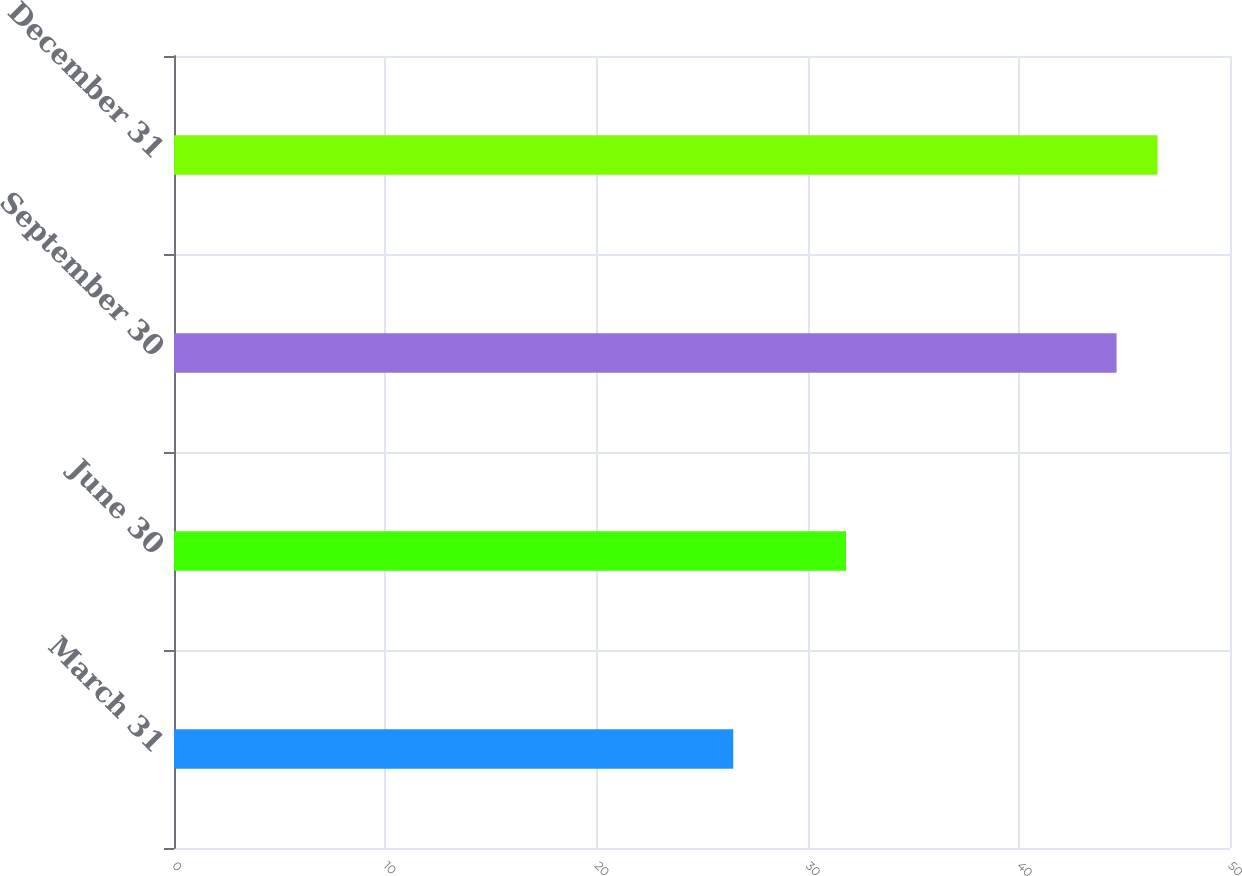<chart> <loc_0><loc_0><loc_500><loc_500><bar_chart><fcel>March 31<fcel>June 30<fcel>September 30<fcel>December 31<nl><fcel>26.48<fcel>31.82<fcel>44.63<fcel>46.57<nl></chart> 